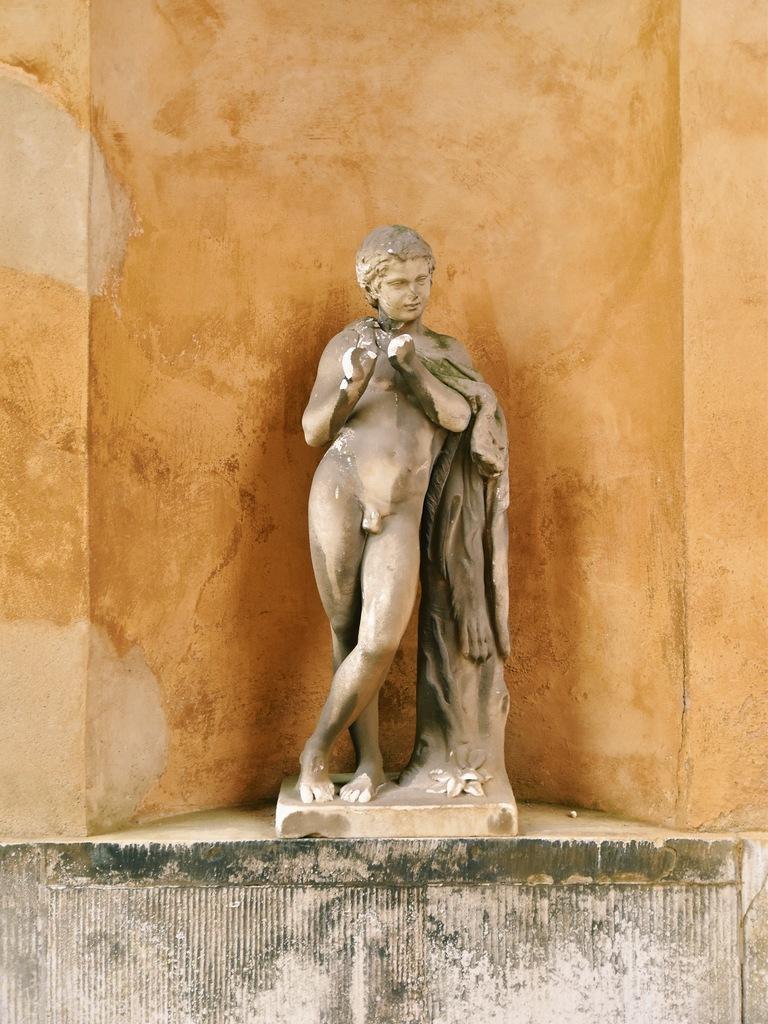Please provide a concise description of this image. In this image there is a sculpture of a person on the wall, the background of the sculptor is orange color. 